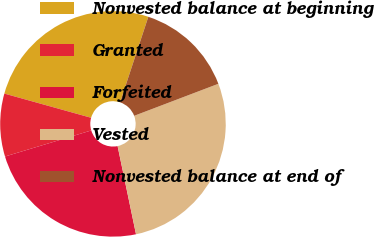Convert chart to OTSL. <chart><loc_0><loc_0><loc_500><loc_500><pie_chart><fcel>Nonvested balance at beginning<fcel>Granted<fcel>Forfeited<fcel>Vested<fcel>Nonvested balance at end of<nl><fcel>25.75%<fcel>9.0%<fcel>23.61%<fcel>27.51%<fcel>14.14%<nl></chart> 